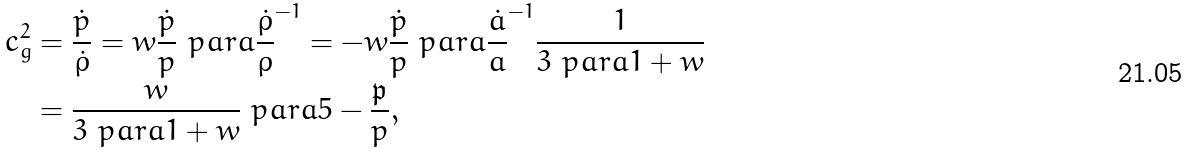Convert formula to latex. <formula><loc_0><loc_0><loc_500><loc_500>c _ { g } ^ { 2 } & = \frac { \dot { p } } { \dot { \rho } } = w \frac { \dot { p } } { p } \ p a r a { \frac { \dot { \rho } } { \rho } } ^ { - 1 } = - w \frac { \dot { p } } { p } \ p a r a { \frac { \dot { a } } { a } } ^ { - 1 } \frac { 1 } { 3 \ p a r a { 1 + w } } \\ & = \frac { w } { 3 \ p a r a { 1 + w } } \ p a r a { 5 - \frac { \mathfrak { p } } { p } } ,</formula> 